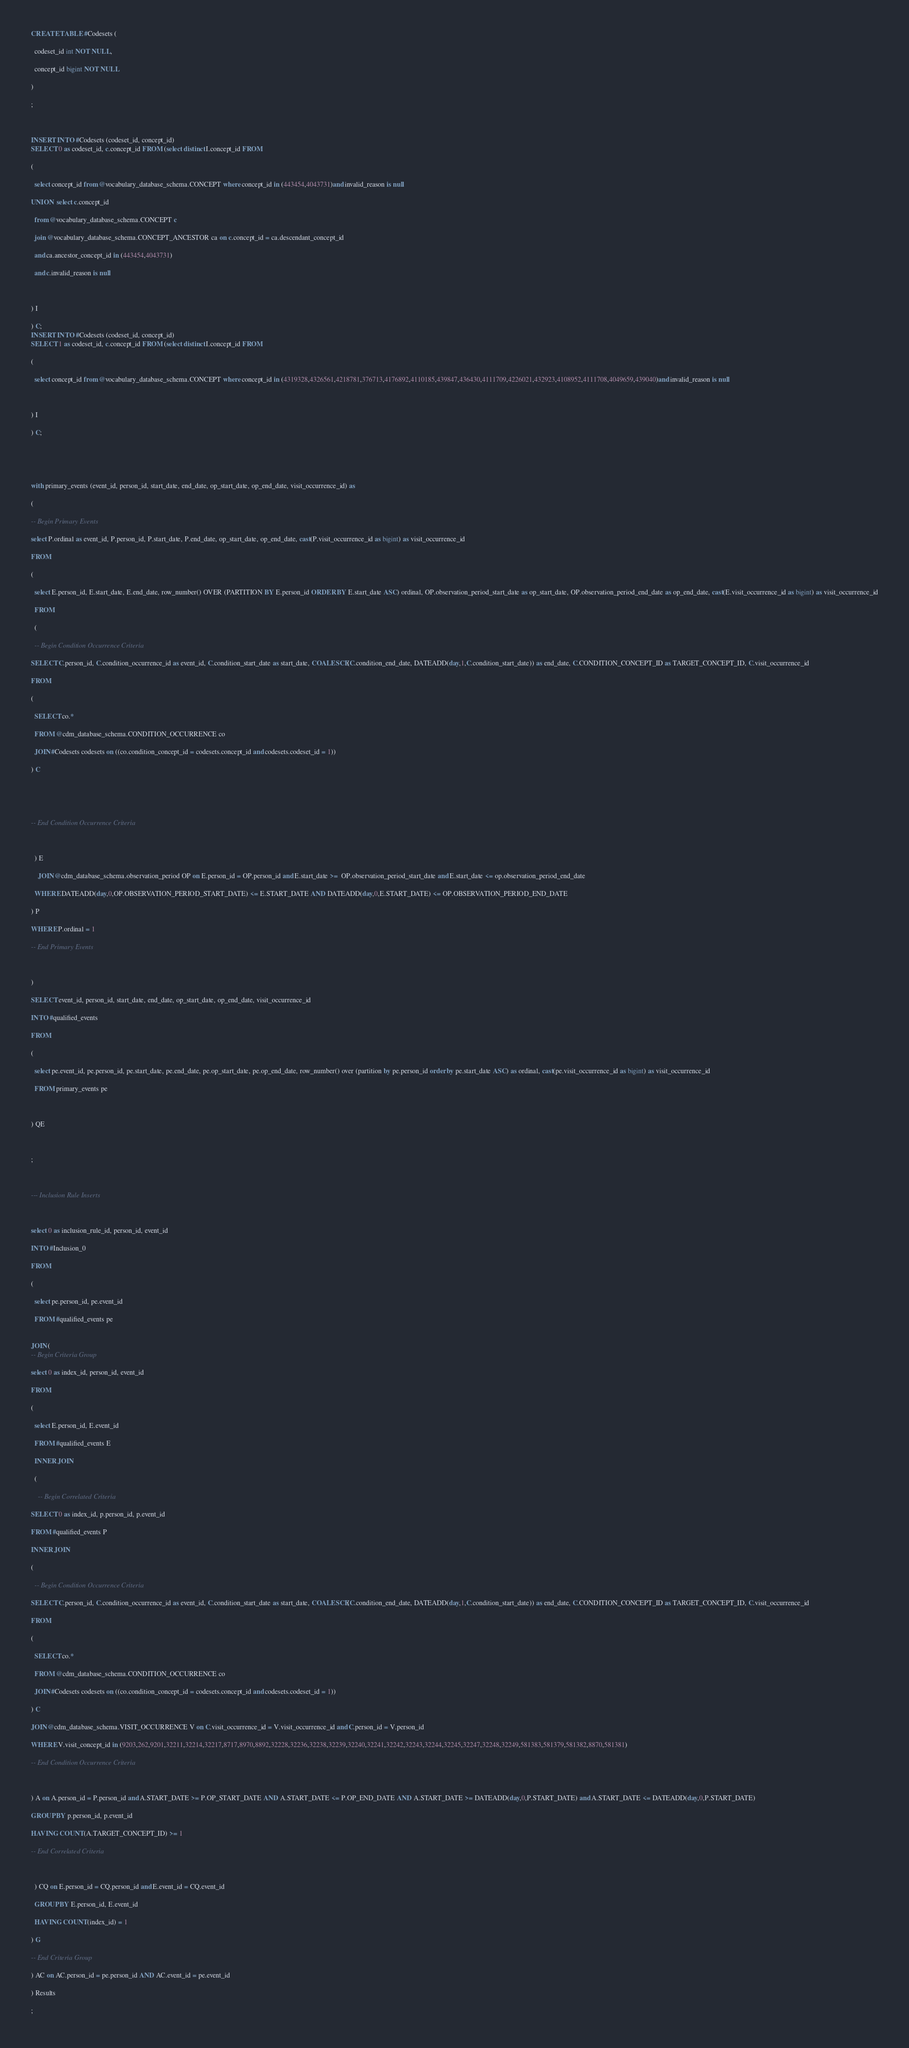Convert code to text. <code><loc_0><loc_0><loc_500><loc_500><_SQL_>CREATE TABLE #Codesets (
  codeset_id int NOT NULL,
  concept_id bigint NOT NULL
)
;

INSERT INTO #Codesets (codeset_id, concept_id)
SELECT 0 as codeset_id, c.concept_id FROM (select distinct I.concept_id FROM
( 
  select concept_id from @vocabulary_database_schema.CONCEPT where concept_id in (443454,4043731)and invalid_reason is null
UNION  select c.concept_id
  from @vocabulary_database_schema.CONCEPT c
  join @vocabulary_database_schema.CONCEPT_ANCESTOR ca on c.concept_id = ca.descendant_concept_id
  and ca.ancestor_concept_id in (443454,4043731)
  and c.invalid_reason is null

) I
) C;
INSERT INTO #Codesets (codeset_id, concept_id)
SELECT 1 as codeset_id, c.concept_id FROM (select distinct I.concept_id FROM
( 
  select concept_id from @vocabulary_database_schema.CONCEPT where concept_id in (4319328,4326561,4218781,376713,4176892,4110185,439847,436430,4111709,4226021,432923,4108952,4111708,4049659,439040)and invalid_reason is null

) I
) C;


with primary_events (event_id, person_id, start_date, end_date, op_start_date, op_end_date, visit_occurrence_id) as
(
-- Begin Primary Events
select P.ordinal as event_id, P.person_id, P.start_date, P.end_date, op_start_date, op_end_date, cast(P.visit_occurrence_id as bigint) as visit_occurrence_id
FROM
(
  select E.person_id, E.start_date, E.end_date, row_number() OVER (PARTITION BY E.person_id ORDER BY E.start_date ASC) ordinal, OP.observation_period_start_date as op_start_date, OP.observation_period_end_date as op_end_date, cast(E.visit_occurrence_id as bigint) as visit_occurrence_id
  FROM 
  (
  -- Begin Condition Occurrence Criteria
SELECT C.person_id, C.condition_occurrence_id as event_id, C.condition_start_date as start_date, COALESCE(C.condition_end_date, DATEADD(day,1,C.condition_start_date)) as end_date, C.CONDITION_CONCEPT_ID as TARGET_CONCEPT_ID, C.visit_occurrence_id
FROM 
(
  SELECT co.* 
  FROM @cdm_database_schema.CONDITION_OCCURRENCE co
  JOIN #Codesets codesets on ((co.condition_concept_id = codesets.concept_id and codesets.codeset_id = 1))
) C


-- End Condition Occurrence Criteria

  ) E
	JOIN @cdm_database_schema.observation_period OP on E.person_id = OP.person_id and E.start_date >=  OP.observation_period_start_date and E.start_date <= op.observation_period_end_date
  WHERE DATEADD(day,0,OP.OBSERVATION_PERIOD_START_DATE) <= E.START_DATE AND DATEADD(day,0,E.START_DATE) <= OP.OBSERVATION_PERIOD_END_DATE
) P
WHERE P.ordinal = 1
-- End Primary Events

)
SELECT event_id, person_id, start_date, end_date, op_start_date, op_end_date, visit_occurrence_id
INTO #qualified_events
FROM 
(
  select pe.event_id, pe.person_id, pe.start_date, pe.end_date, pe.op_start_date, pe.op_end_date, row_number() over (partition by pe.person_id order by pe.start_date ASC) as ordinal, cast(pe.visit_occurrence_id as bigint) as visit_occurrence_id
  FROM primary_events pe
  
) QE

;

--- Inclusion Rule Inserts

select 0 as inclusion_rule_id, person_id, event_id
INTO #Inclusion_0
FROM 
(
  select pe.person_id, pe.event_id
  FROM #qualified_events pe
  
JOIN (
-- Begin Criteria Group
select 0 as index_id, person_id, event_id
FROM
(
  select E.person_id, E.event_id 
  FROM #qualified_events E
  INNER JOIN
  (
    -- Begin Correlated Criteria
SELECT 0 as index_id, p.person_id, p.event_id
FROM #qualified_events P
INNER JOIN
(
  -- Begin Condition Occurrence Criteria
SELECT C.person_id, C.condition_occurrence_id as event_id, C.condition_start_date as start_date, COALESCE(C.condition_end_date, DATEADD(day,1,C.condition_start_date)) as end_date, C.CONDITION_CONCEPT_ID as TARGET_CONCEPT_ID, C.visit_occurrence_id
FROM 
(
  SELECT co.* 
  FROM @cdm_database_schema.CONDITION_OCCURRENCE co
  JOIN #Codesets codesets on ((co.condition_concept_id = codesets.concept_id and codesets.codeset_id = 1))
) C
JOIN @cdm_database_schema.VISIT_OCCURRENCE V on C.visit_occurrence_id = V.visit_occurrence_id and C.person_id = V.person_id
WHERE V.visit_concept_id in (9203,262,9201,32211,32214,32217,8717,8970,8892,32228,32236,32238,32239,32240,32241,32242,32243,32244,32245,32247,32248,32249,581383,581379,581382,8870,581381)
-- End Condition Occurrence Criteria

) A on A.person_id = P.person_id and A.START_DATE >= P.OP_START_DATE AND A.START_DATE <= P.OP_END_DATE AND A.START_DATE >= DATEADD(day,0,P.START_DATE) and A.START_DATE <= DATEADD(day,0,P.START_DATE)
GROUP BY p.person_id, p.event_id
HAVING COUNT(A.TARGET_CONCEPT_ID) >= 1
-- End Correlated Criteria

  ) CQ on E.person_id = CQ.person_id and E.event_id = CQ.event_id
  GROUP BY E.person_id, E.event_id
  HAVING COUNT(index_id) = 1
) G
-- End Criteria Group
) AC on AC.person_id = pe.person_id AND AC.event_id = pe.event_id
) Results
;
</code> 